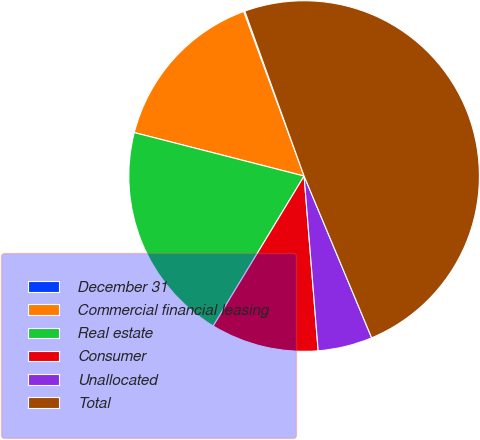Convert chart. <chart><loc_0><loc_0><loc_500><loc_500><pie_chart><fcel>December 31<fcel>Commercial financial leasing<fcel>Real estate<fcel>Consumer<fcel>Unallocated<fcel>Total<nl><fcel>0.11%<fcel>15.41%<fcel>20.32%<fcel>9.95%<fcel>5.02%<fcel>49.2%<nl></chart> 